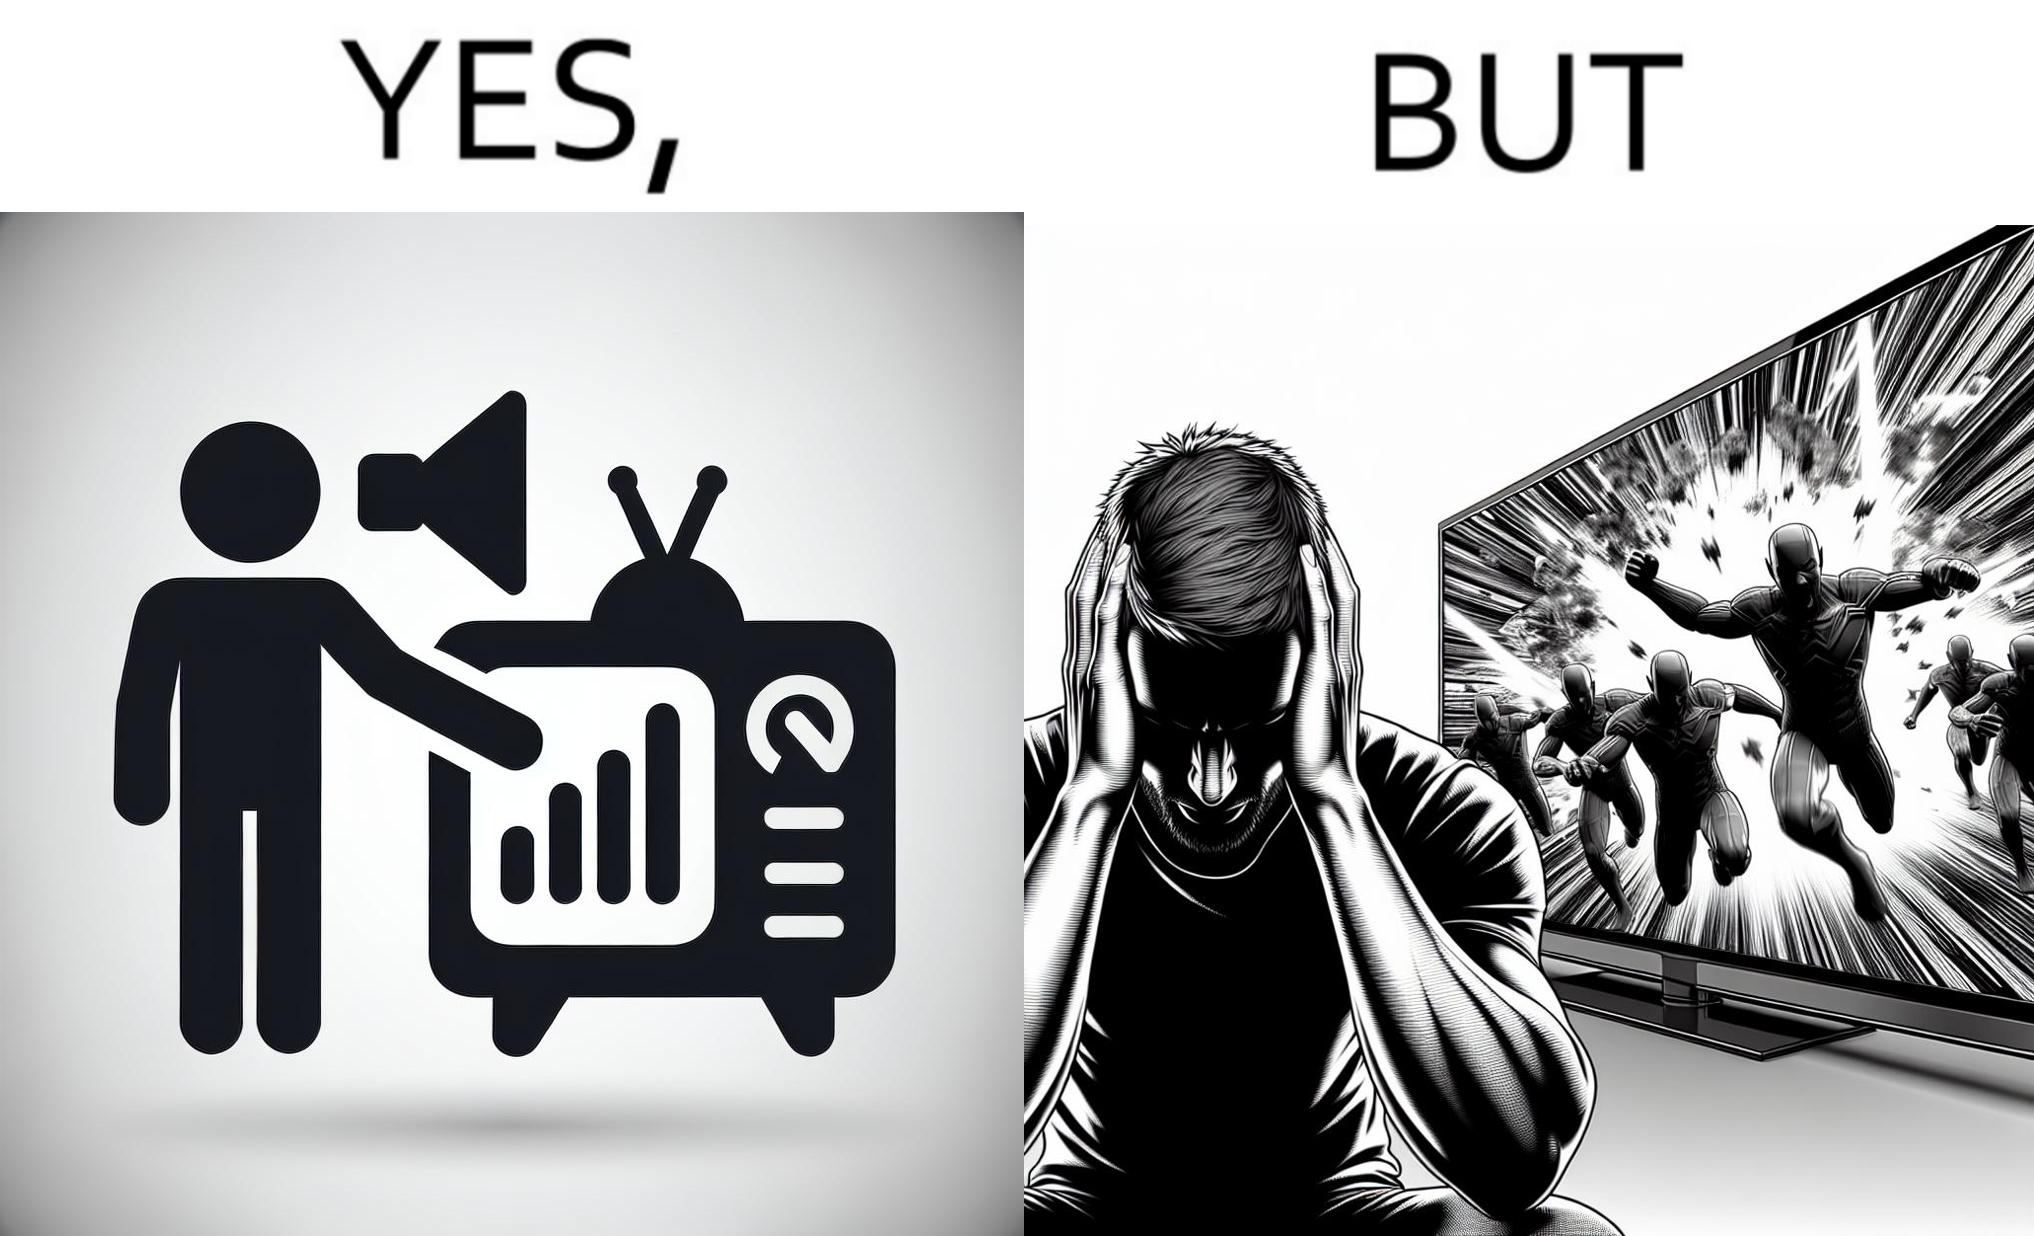Describe the satirical element in this image. The action scenes of the movies or TV programs are mostly low in sound and people aren't able to hear them properly but in the action scenes due to the background music and other noise the sound becomes unbearable to some peoples 